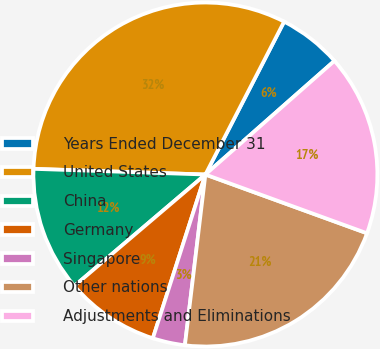<chart> <loc_0><loc_0><loc_500><loc_500><pie_chart><fcel>Years Ended December 31<fcel>United States<fcel>China<fcel>Germany<fcel>Singapore<fcel>Other nations<fcel>Adjustments and Eliminations<nl><fcel>5.94%<fcel>32.04%<fcel>11.74%<fcel>8.84%<fcel>3.04%<fcel>21.35%<fcel>17.04%<nl></chart> 